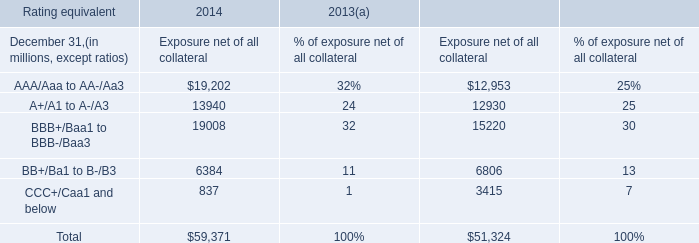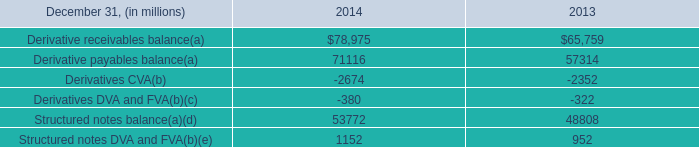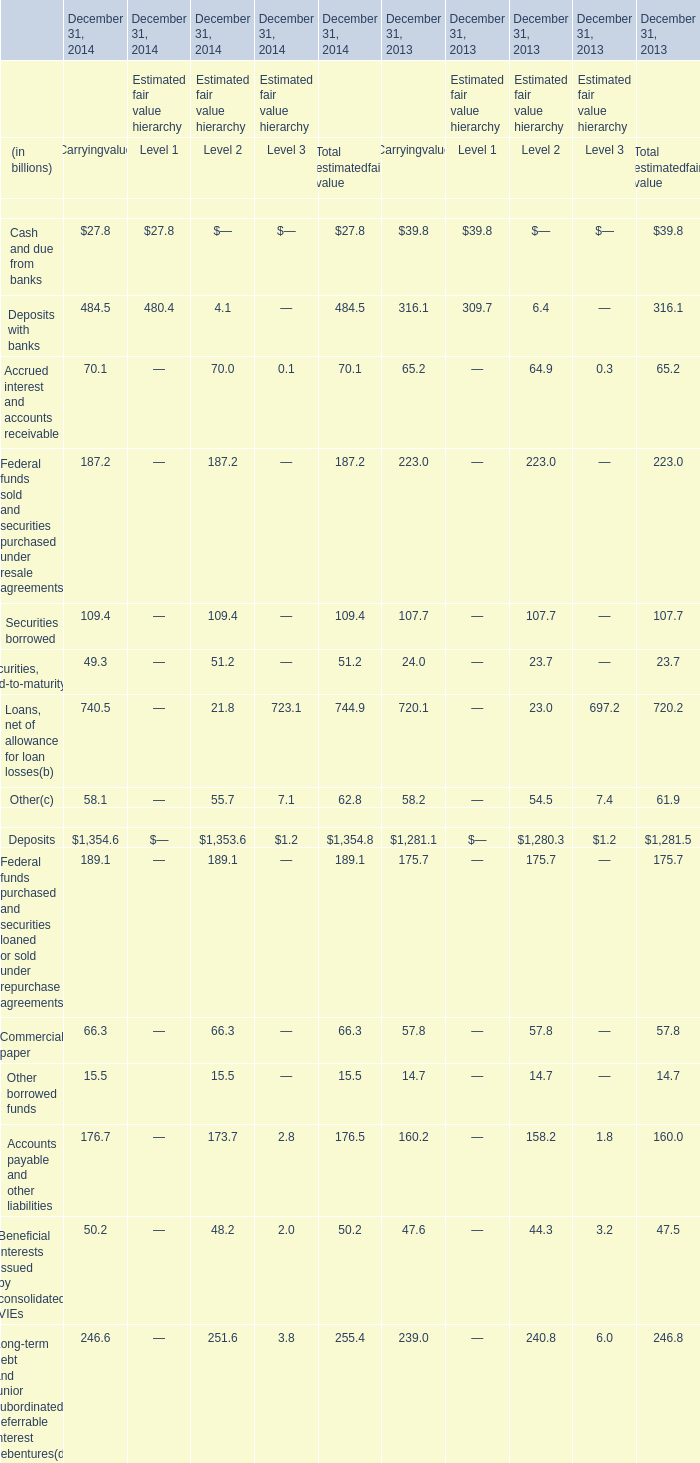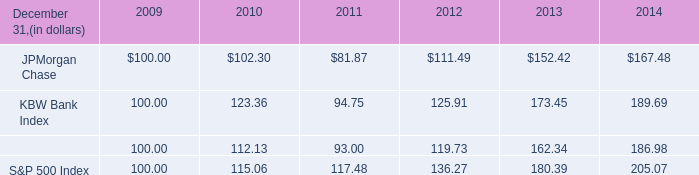What is the sum of Level 1 in 2014 ? (in billion) 
Computations: (27.8 + 480.4)
Answer: 508.2. 